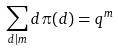Convert formula to latex. <formula><loc_0><loc_0><loc_500><loc_500>\sum _ { d | m } d \pi ( d ) = q ^ { m }</formula> 